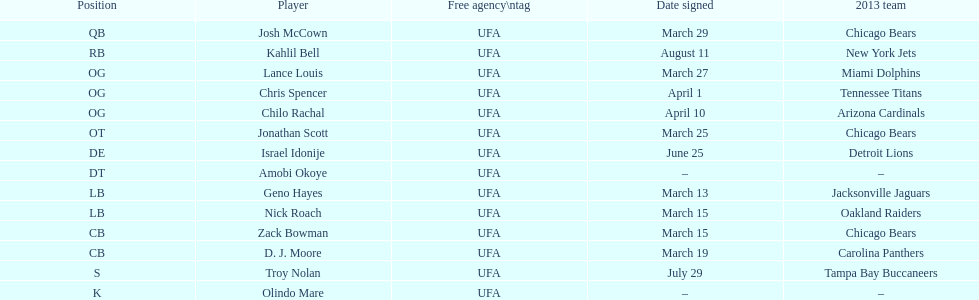How many available players did this team add this season? 14. Could you parse the entire table as a dict? {'header': ['Position', 'Player', 'Free agency\\ntag', 'Date signed', '2013 team'], 'rows': [['QB', 'Josh McCown', 'UFA', 'March 29', 'Chicago Bears'], ['RB', 'Kahlil Bell', 'UFA', 'August 11', 'New York Jets'], ['OG', 'Lance Louis', 'UFA', 'March 27', 'Miami Dolphins'], ['OG', 'Chris Spencer', 'UFA', 'April 1', 'Tennessee Titans'], ['OG', 'Chilo Rachal', 'UFA', 'April 10', 'Arizona Cardinals'], ['OT', 'Jonathan Scott', 'UFA', 'March 25', 'Chicago Bears'], ['DE', 'Israel Idonije', 'UFA', 'June 25', 'Detroit Lions'], ['DT', 'Amobi Okoye', 'UFA', '–', '–'], ['LB', 'Geno Hayes', 'UFA', 'March 13', 'Jacksonville Jaguars'], ['LB', 'Nick Roach', 'UFA', 'March 15', 'Oakland Raiders'], ['CB', 'Zack Bowman', 'UFA', 'March 15', 'Chicago Bears'], ['CB', 'D. J. Moore', 'UFA', 'March 19', 'Carolina Panthers'], ['S', 'Troy Nolan', 'UFA', 'July 29', 'Tampa Bay Buccaneers'], ['K', 'Olindo Mare', 'UFA', '–', '–']]} 